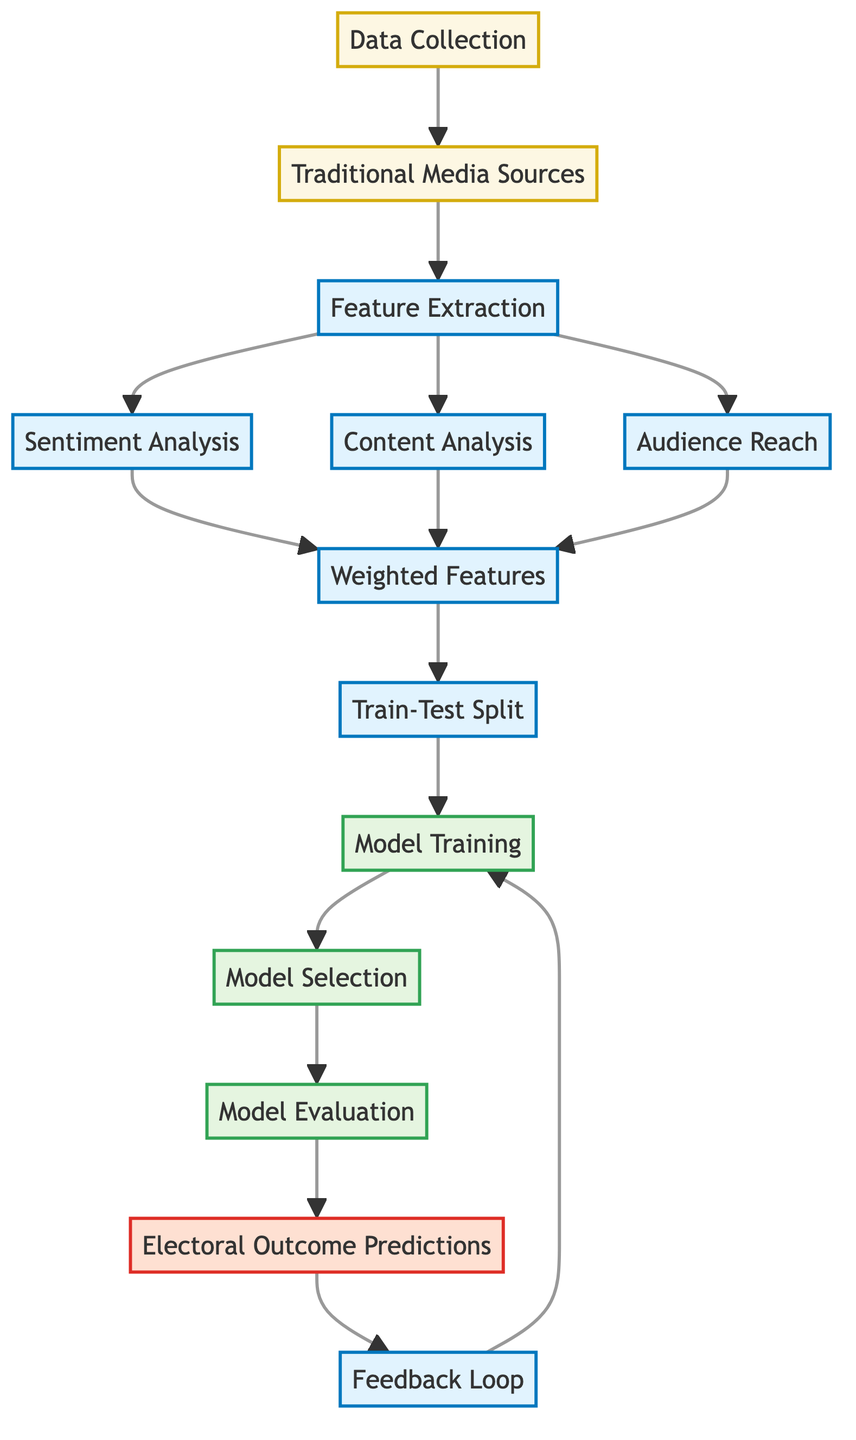What is the first node in the diagram? The diagram starts with the "Data Collection" node, indicating that data gathering is the first step in the process.
Answer: Data Collection How many processes are there in the diagram? There are five processes illustrated: Feature Extraction, Sentiment Analysis, Content Analysis, Audience Reach, and Model Training. Counting these gives a total of five processes.
Answer: Five What type of analysis is included in the feature extraction step? The feature extraction step includes three types of analysis: Sentiment Analysis, Content Analysis, and Audience Reach. Therefore, the type of analysis is "multiple."
Answer: Multiple What happens after the "Model Selection" node? After selecting the model, the next step indicated in the diagram is "Model Evaluation," which assesses the performance of the selected model.
Answer: Model Evaluation What feedback loop is present in the diagram? The feedback loop connects "Predictions" back to "Model Training," indicating that the outcomes feed back into the model for retraining and improvement.
Answer: Model Training Which node comes after "Weighted Features"? The node that follows "Weighted Features" is "Train-Test Split," which divides the dataset into training and testing subsets for model evaluation.
Answer: Train-Test Split How many output nodes are shown in the diagram? There is one output node labeled "Electoral Outcome Predictions," which is focused on the results derived from the model evaluation process. Thus, the count is one.
Answer: One Which stage involves the analysis of audience reach? Audience reach is analyzed during the "Feature Extraction" process, indicating its importance in understanding the impact of traditional media.
Answer: Feature Extraction What is the main purpose of the "Feedback Loop"? The main purpose of the feedback loop is to improve the "Model Training" based on the "Electoral Outcome Predictions." This iterative process ensures model refinement.
Answer: Model Training 